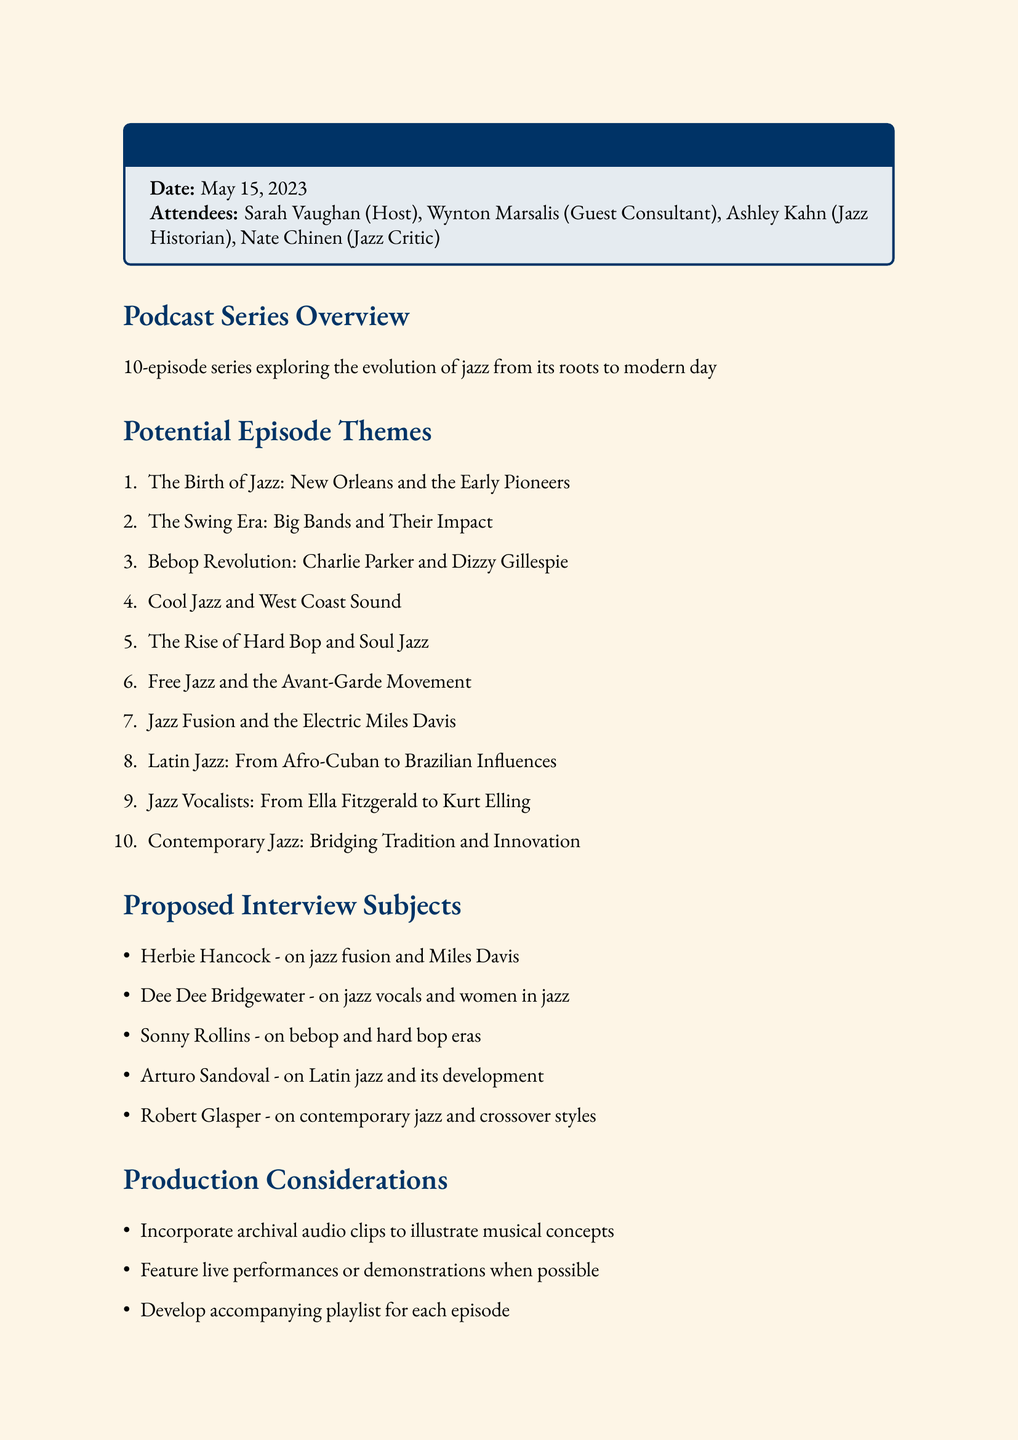What is the date of the meeting? The date of the meeting is mentioned in the document, which is May 15, 2023.
Answer: May 15, 2023 Who hosted the brainstorming session? The host of the session is listed as Sarah Vaughan in the attendee section.
Answer: Sarah Vaughan How many episodes are planned for the podcast series? The podcast series overview indicates a total of 10 episodes will be included.
Answer: 10 Name one proposed interview subject. The proposed interview subjects are listed, and one example is Herbie Hancock.
Answer: Herbie Hancock What theme focuses on vocalists? The document includes a theme specifically for vocalists titled "Jazz Vocalists: From Ella Fitzgerald to Kurt Elling."
Answer: Jazz Vocalists: From Ella Fitzgerald to Kurt Elling What production consideration involves music clips? The production considerations include incorporating archival audio clips to illustrate musical concepts.
Answer: Incorporate archival audio clips What is one next step mentioned in the document? One of the next steps outlined is to begin reaching out to potential interview subjects.
Answer: Begin reaching out to potential interview subjects Which era is mentioned as part of the potential episode themes? The theme for "The Swing Era: Big Bands and Their Impact" pertains to a specific time in jazz history discussed.
Answer: The Swing Era: Big Bands and Their Impact Who is listed as a guest consultant? The document specifies Wynton Marsalis as the guest consultant attending the meeting.
Answer: Wynton Marsalis 